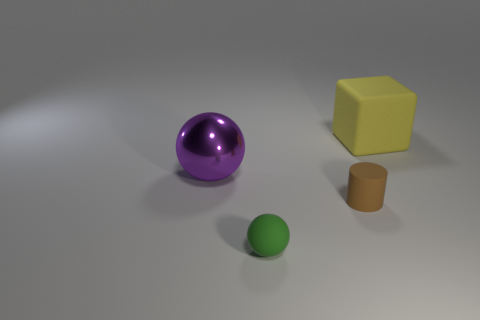Add 3 small blue matte cylinders. How many objects exist? 7 Subtract all cubes. How many objects are left? 3 Subtract all small brown cylinders. Subtract all metal spheres. How many objects are left? 2 Add 4 small brown matte things. How many small brown matte things are left? 5 Add 3 large matte objects. How many large matte objects exist? 4 Subtract 0 cyan cubes. How many objects are left? 4 